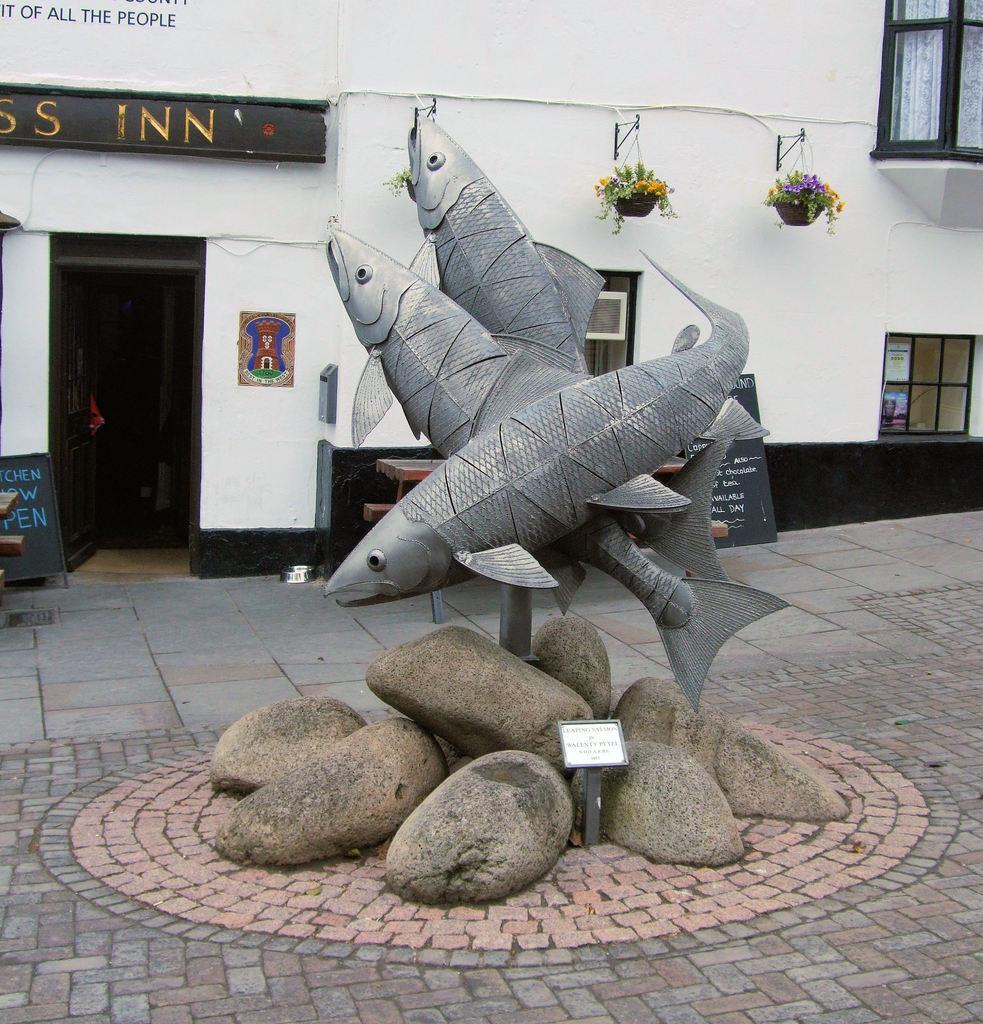Can you describe this image briefly? In this picture I can see a sculpture of fishes, there are boards, rocks, and in the background there is a building with windows and there are plants. 